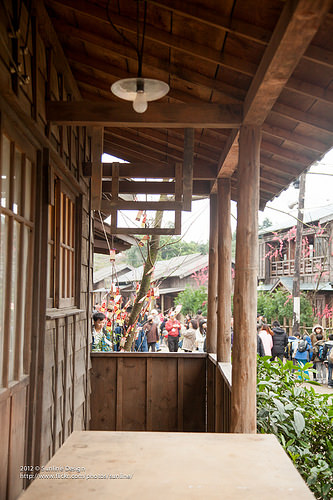<image>
Can you confirm if the house is behind the tree? Yes. From this viewpoint, the house is positioned behind the tree, with the tree partially or fully occluding the house. 